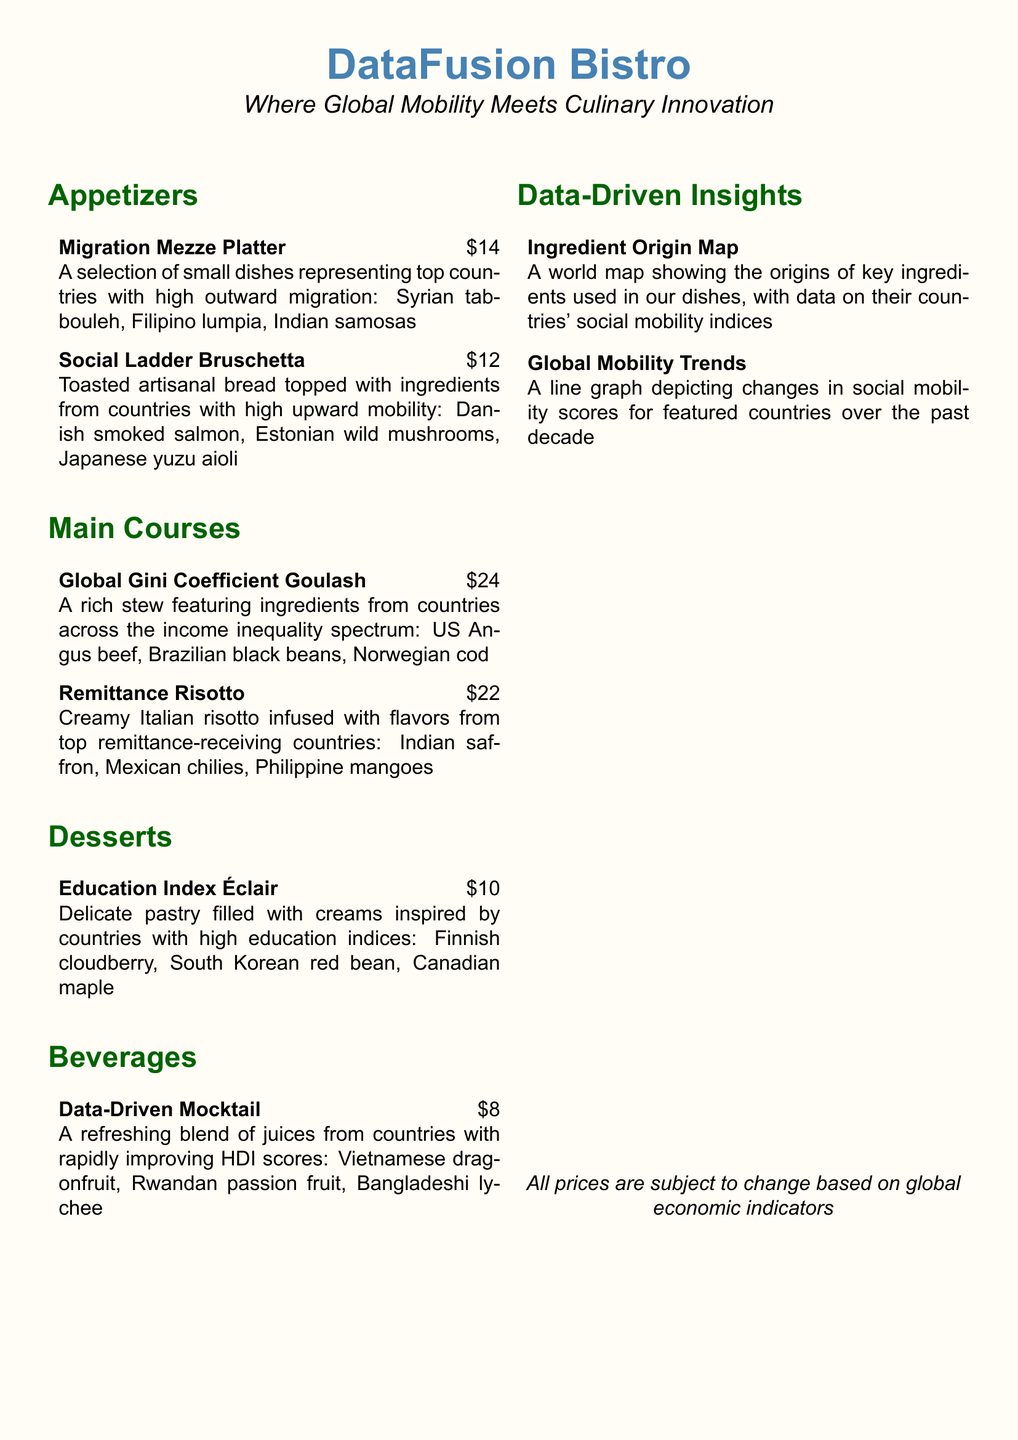What is the name of the appetizer featuring dishes from high outward migration countries? The appetizer is named "Migration Mezze Platter," which includes Syrian tabbouleh, Filipino lumpia, and Indian samosas.
Answer: Migration Mezze Platter What is the price of the Social Ladder Bruschetta? The price listed for the Social Ladder Bruschetta is $12.
Answer: $12 Which main course features ingredients from countries across the income inequality spectrum? The main course featuring these ingredients is called "Global Gini Coefficient Goulash."
Answer: Global Gini Coefficient Goulash What ingredient is used in the Education Index Éclair that comes from Finland? The ingredient from Finland used in the Education Index Éclair is cloudberry.
Answer: cloudberry What refreshing beverage includes Vietnamese dragonfruit? The beverage is named "Data-Driven Mocktail."
Answer: Data-Driven Mocktail How many appetizers are listed on the menu? There are two appetizers mentioned in the menu.
Answer: 2 Which country is associated with the saffron used in the Remittance Risotto? The country associated with the saffron is India.
Answer: India What does the menu suggest might cause price changes? The menu indicates that prices are subject to change based on global economic indicators.
Answer: global economic indicators What type of data visualization is shown on the ingredient origin map? The ingredient origin map displays a world map with the origins of key ingredients and their countries' social mobility indices.
Answer: world map 